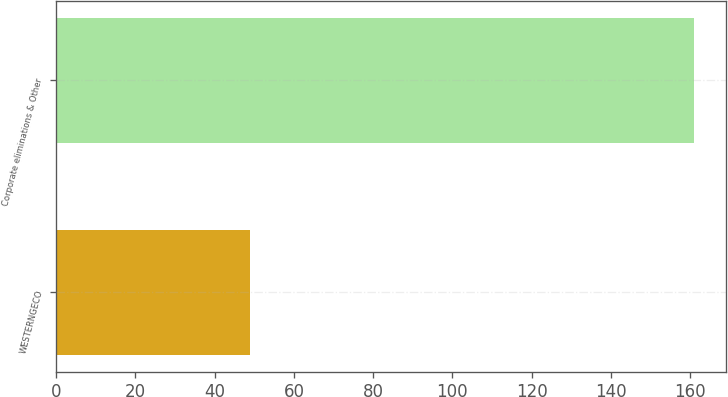<chart> <loc_0><loc_0><loc_500><loc_500><bar_chart><fcel>WESTERNGECO<fcel>Corporate eliminations & Other<nl><fcel>49<fcel>161<nl></chart> 